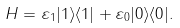Convert formula to latex. <formula><loc_0><loc_0><loc_500><loc_500>H = \varepsilon _ { 1 } | 1 \rangle \langle 1 | + \varepsilon _ { 0 } | 0 \rangle \langle 0 | .</formula> 